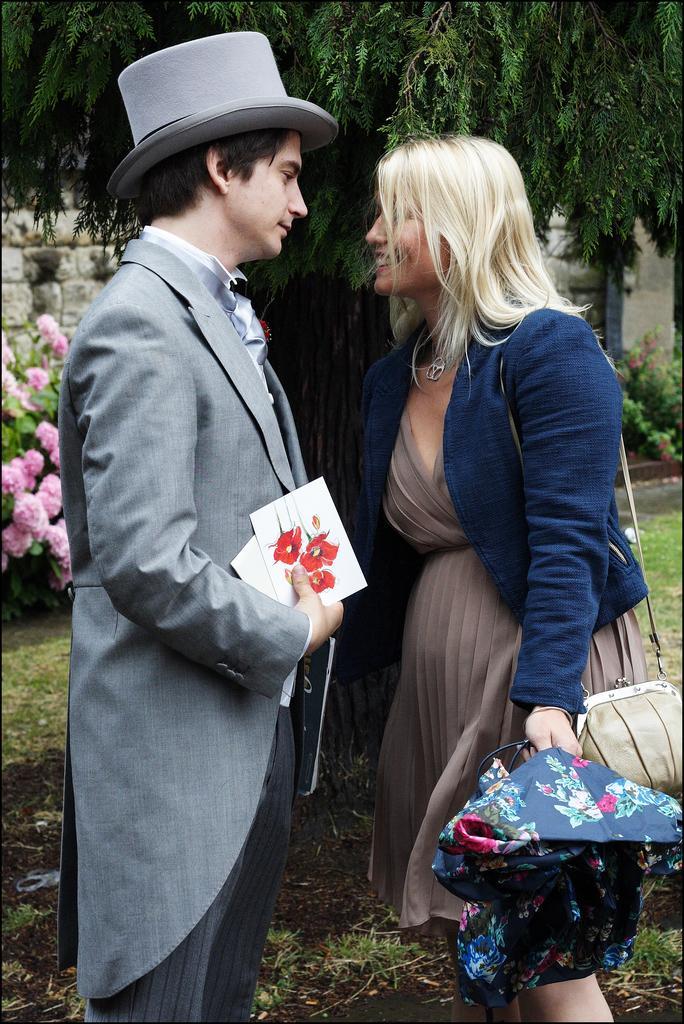Please provide a concise description of this image. On the left side of the image there is a man with a hat on his head and holding papers in his hand. In front of him there is a lady with bag and an umbrella is standing. Behind them there is a tree. On the left side of the image there is a plant with flowers. 